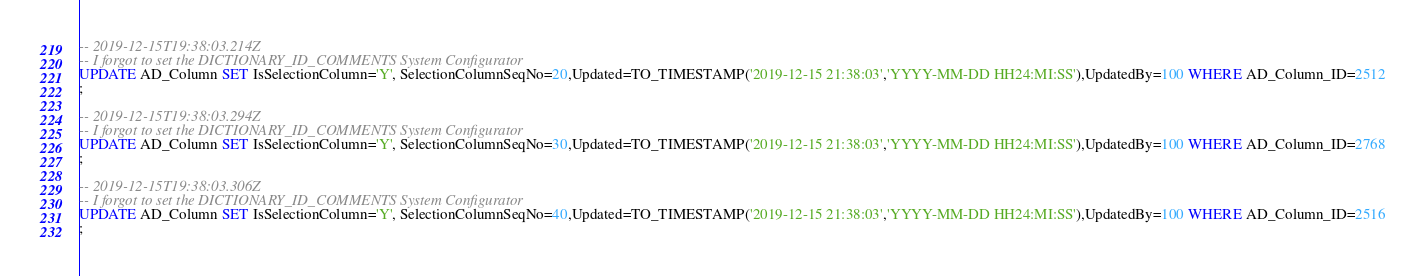Convert code to text. <code><loc_0><loc_0><loc_500><loc_500><_SQL_>-- 2019-12-15T19:38:03.214Z
-- I forgot to set the DICTIONARY_ID_COMMENTS System Configurator
UPDATE AD_Column SET IsSelectionColumn='Y', SelectionColumnSeqNo=20,Updated=TO_TIMESTAMP('2019-12-15 21:38:03','YYYY-MM-DD HH24:MI:SS'),UpdatedBy=100 WHERE AD_Column_ID=2512
;

-- 2019-12-15T19:38:03.294Z
-- I forgot to set the DICTIONARY_ID_COMMENTS System Configurator
UPDATE AD_Column SET IsSelectionColumn='Y', SelectionColumnSeqNo=30,Updated=TO_TIMESTAMP('2019-12-15 21:38:03','YYYY-MM-DD HH24:MI:SS'),UpdatedBy=100 WHERE AD_Column_ID=2768
;

-- 2019-12-15T19:38:03.306Z
-- I forgot to set the DICTIONARY_ID_COMMENTS System Configurator
UPDATE AD_Column SET IsSelectionColumn='Y', SelectionColumnSeqNo=40,Updated=TO_TIMESTAMP('2019-12-15 21:38:03','YYYY-MM-DD HH24:MI:SS'),UpdatedBy=100 WHERE AD_Column_ID=2516
;
</code> 